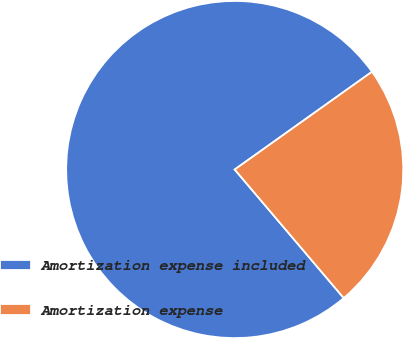Convert chart to OTSL. <chart><loc_0><loc_0><loc_500><loc_500><pie_chart><fcel>Amortization expense included<fcel>Amortization expense<nl><fcel>76.35%<fcel>23.65%<nl></chart> 